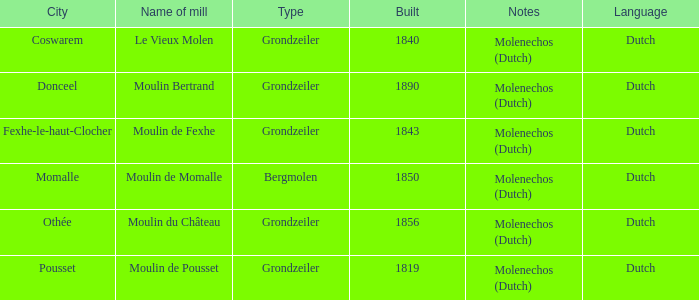Would you mind parsing the complete table? {'header': ['City', 'Name of mill', 'Type', 'Built', 'Notes', 'Language'], 'rows': [['Coswarem', 'Le Vieux Molen', 'Grondzeiler', '1840', 'Molenechos (Dutch)', 'Dutch'], ['Donceel', 'Moulin Bertrand', 'Grondzeiler', '1890', 'Molenechos (Dutch)', 'Dutch'], ['Fexhe-le-haut-Clocher', 'Moulin de Fexhe', 'Grondzeiler', '1843', 'Molenechos (Dutch)', 'Dutch'], ['Momalle', 'Moulin de Momalle', 'Bergmolen', '1850', 'Molenechos (Dutch)', 'Dutch'], ['Othée', 'Moulin du Château', 'Grondzeiler', '1856', 'Molenechos (Dutch)', 'Dutch'], ['Pousset', 'Moulin de Pousset', 'Grondzeiler', '1819', 'Molenechos (Dutch)', 'Dutch']]} What is the Name of the Grondzeiler Mill? Le Vieux Molen, Moulin Bertrand, Moulin de Fexhe, Moulin du Château, Moulin de Pousset. 